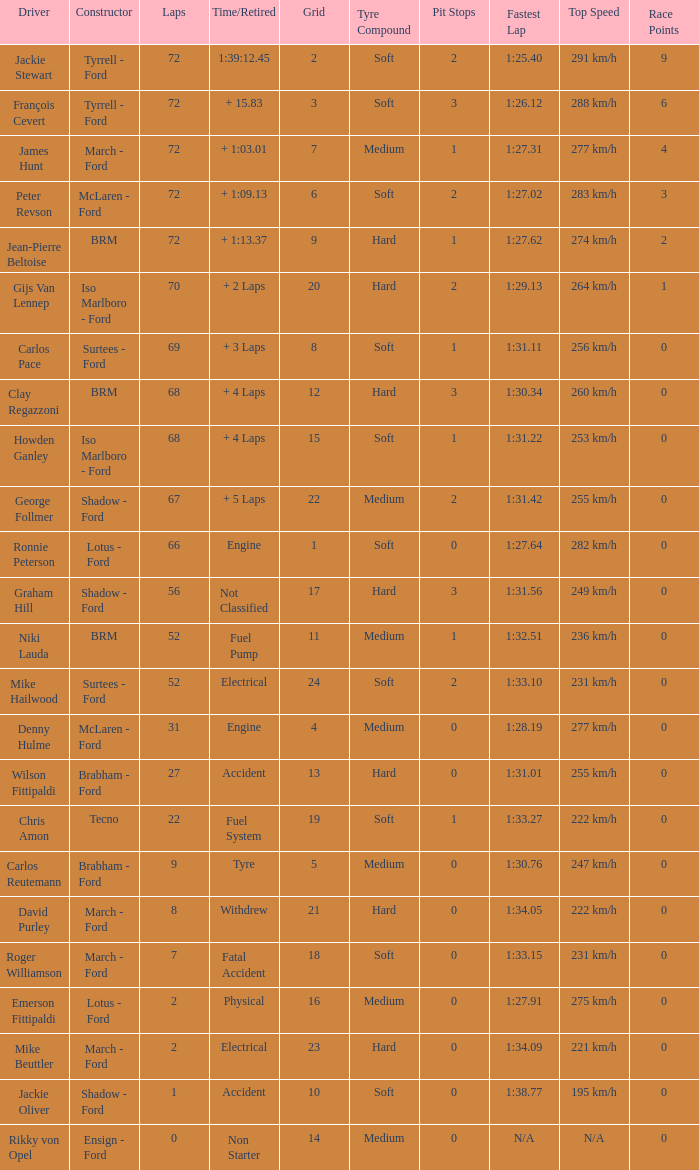What is the top lap that had a tyre time? 9.0. 